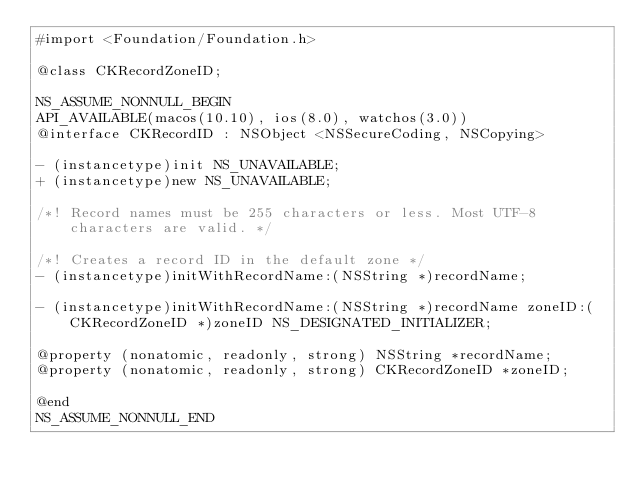<code> <loc_0><loc_0><loc_500><loc_500><_C_>#import <Foundation/Foundation.h>

@class CKRecordZoneID;

NS_ASSUME_NONNULL_BEGIN
API_AVAILABLE(macos(10.10), ios(8.0), watchos(3.0))
@interface CKRecordID : NSObject <NSSecureCoding, NSCopying>

- (instancetype)init NS_UNAVAILABLE;
+ (instancetype)new NS_UNAVAILABLE;

/*! Record names must be 255 characters or less. Most UTF-8 characters are valid. */

/*! Creates a record ID in the default zone */
- (instancetype)initWithRecordName:(NSString *)recordName;

- (instancetype)initWithRecordName:(NSString *)recordName zoneID:(CKRecordZoneID *)zoneID NS_DESIGNATED_INITIALIZER;

@property (nonatomic, readonly, strong) NSString *recordName;
@property (nonatomic, readonly, strong) CKRecordZoneID *zoneID;

@end
NS_ASSUME_NONNULL_END
</code> 